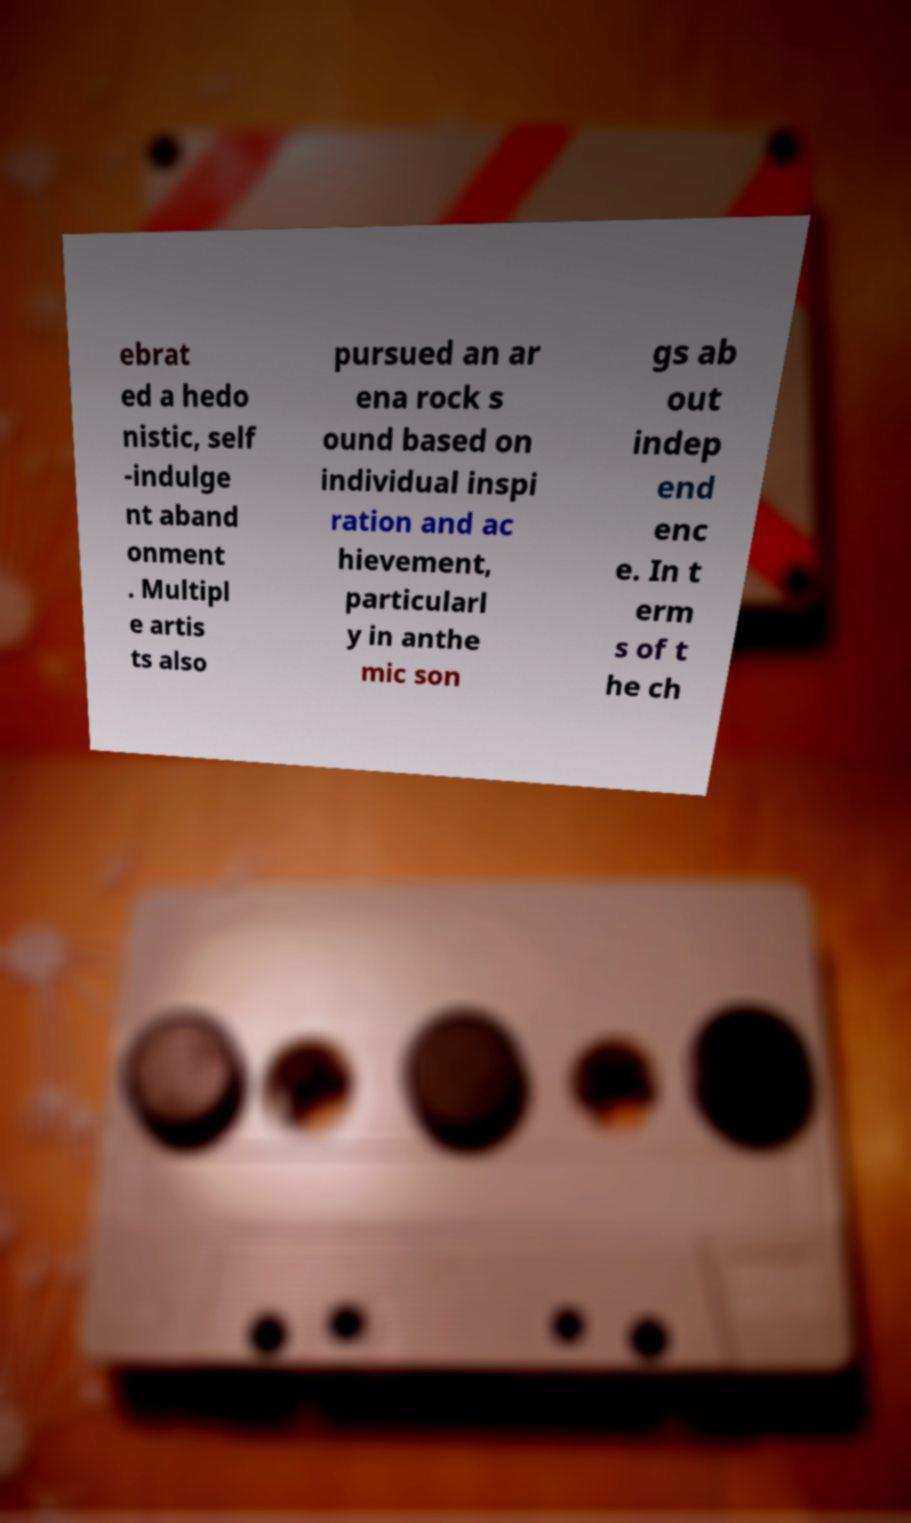Please read and relay the text visible in this image. What does it say? ebrat ed a hedo nistic, self -indulge nt aband onment . Multipl e artis ts also pursued an ar ena rock s ound based on individual inspi ration and ac hievement, particularl y in anthe mic son gs ab out indep end enc e. In t erm s of t he ch 